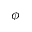<formula> <loc_0><loc_0><loc_500><loc_500>\phi</formula> 